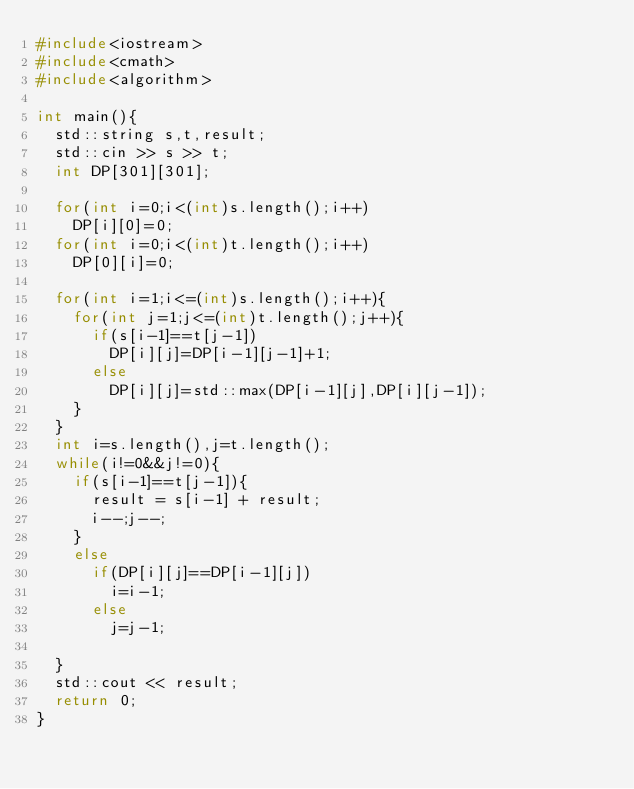Convert code to text. <code><loc_0><loc_0><loc_500><loc_500><_C++_>#include<iostream>
#include<cmath>
#include<algorithm>

int main(){
  std::string s,t,result;
  std::cin >> s >> t;
  int DP[301][301];

  for(int i=0;i<(int)s.length();i++)
    DP[i][0]=0;
  for(int i=0;i<(int)t.length();i++)
    DP[0][i]=0;

  for(int i=1;i<=(int)s.length();i++){
    for(int j=1;j<=(int)t.length();j++){
      if(s[i-1]==t[j-1])
        DP[i][j]=DP[i-1][j-1]+1;
      else
        DP[i][j]=std::max(DP[i-1][j],DP[i][j-1]);
    }
  }
  int i=s.length(),j=t.length();
  while(i!=0&&j!=0){
    if(s[i-1]==t[j-1]){
      result = s[i-1] + result;
      i--;j--;
    }
    else
      if(DP[i][j]==DP[i-1][j])
        i=i-1;
      else
        j=j-1;

  }
  std::cout << result;
  return 0;
}
</code> 